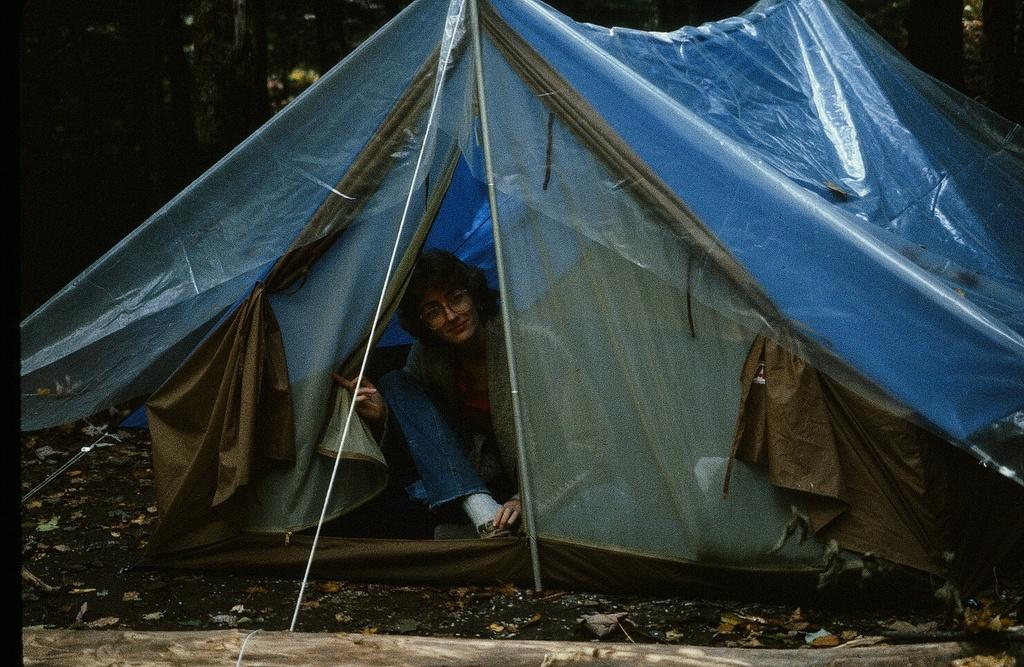What is the main structure in the center of the picture? There is a tent in the center of the picture. Who is inside the tent? There is a woman inside the tent. What can be seen in the foreground of the image? Dry leaves, soil, and a wooden log are present in the foreground. What type of vegetation is visible in the background? Trees are present in the background. What type of wood is the woman using to support her neck in the image? There is no wood or any object being used to support the woman's neck in the image. What meal is being prepared in the image? There is no meal preparation visible in the image. 